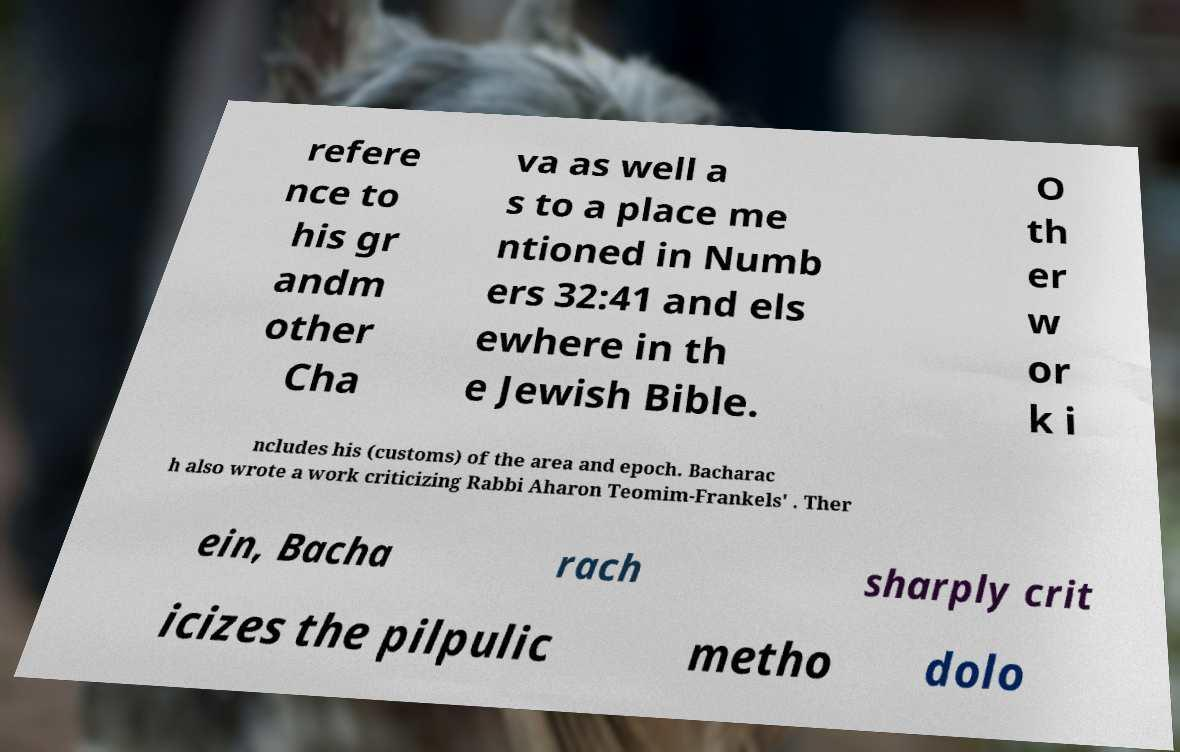Can you accurately transcribe the text from the provided image for me? refere nce to his gr andm other Cha va as well a s to a place me ntioned in Numb ers 32:41 and els ewhere in th e Jewish Bible. O th er w or k i ncludes his (customs) of the area and epoch. Bacharac h also wrote a work criticizing Rabbi Aharon Teomim-Frankels' . Ther ein, Bacha rach sharply crit icizes the pilpulic metho dolo 